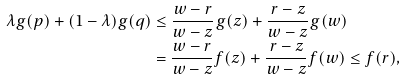Convert formula to latex. <formula><loc_0><loc_0><loc_500><loc_500>\lambda g ( p ) + ( 1 - \lambda ) g ( q ) & \leq \frac { w - r } { w - z } g ( z ) + \frac { r - z } { w - z } g ( w ) \\ & = \frac { w - r } { w - z } f ( z ) + \frac { r - z } { w - z } f ( w ) \leq f ( r ) ,</formula> 